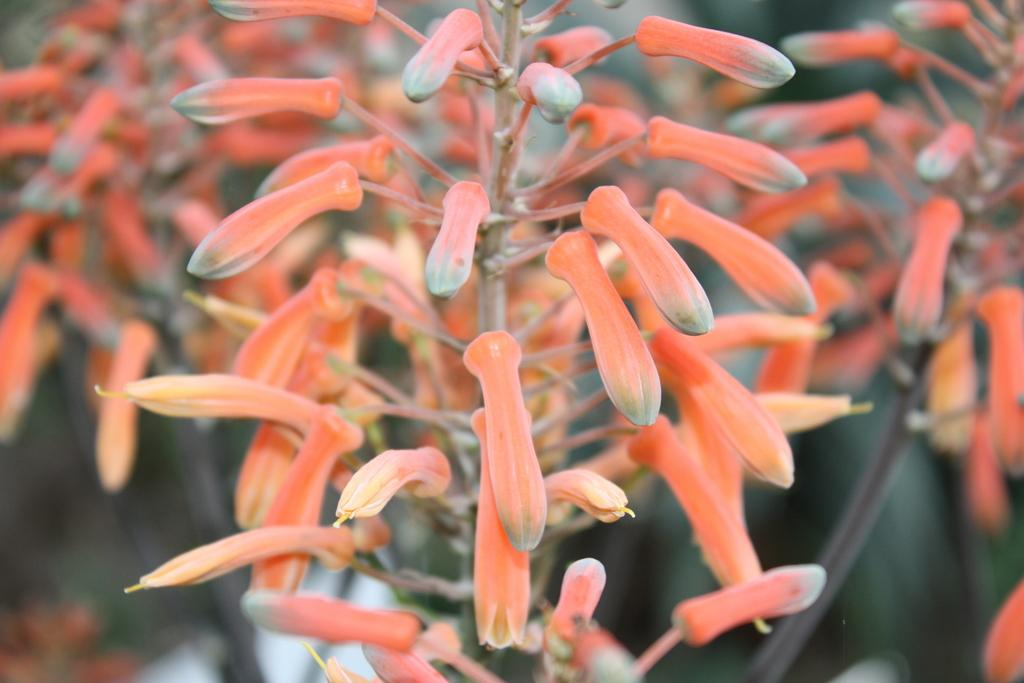What is present in the image? There are buds in the image. Can you describe the background of the image? The background of the image is blurred. What type of protest is happening in the image? There is no protest present in the image; it only features buds and a blurred background. Can you tell me the level of the minister in the image? There is no minister present in the image; it only features buds and a blurred background. 